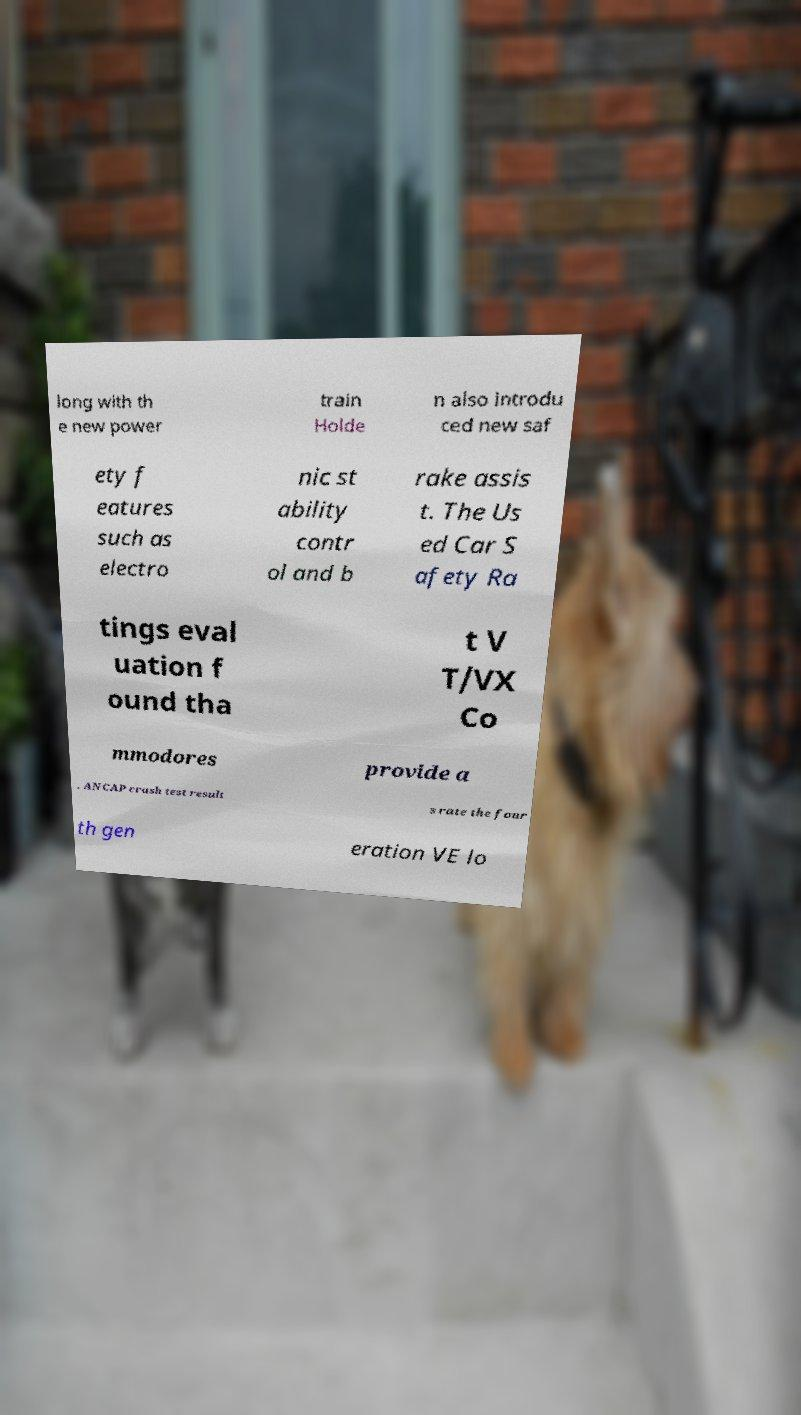What messages or text are displayed in this image? I need them in a readable, typed format. long with th e new power train Holde n also introdu ced new saf ety f eatures such as electro nic st ability contr ol and b rake assis t. The Us ed Car S afety Ra tings eval uation f ound tha t V T/VX Co mmodores provide a . ANCAP crash test result s rate the four th gen eration VE lo 